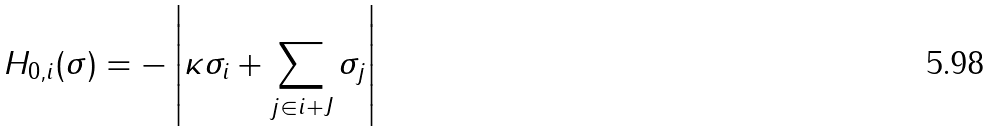<formula> <loc_0><loc_0><loc_500><loc_500>H _ { 0 , i } ( \sigma ) = - \left | \kappa \sigma _ { i } + \sum _ { j \in i + J } \sigma _ { j } \right |</formula> 